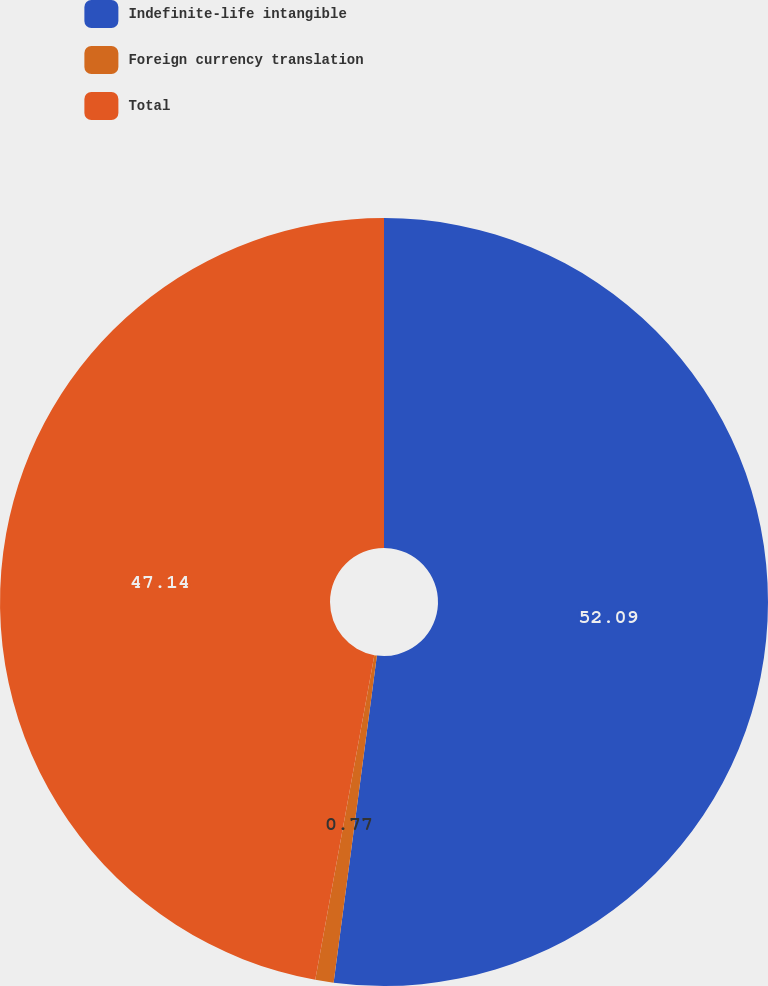Convert chart. <chart><loc_0><loc_0><loc_500><loc_500><pie_chart><fcel>Indefinite-life intangible<fcel>Foreign currency translation<fcel>Total<nl><fcel>52.1%<fcel>0.77%<fcel>47.14%<nl></chart> 